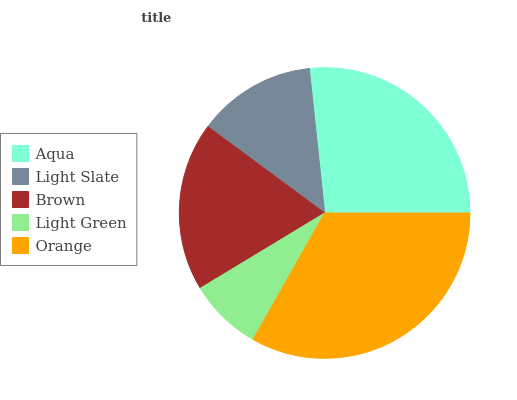Is Light Green the minimum?
Answer yes or no. Yes. Is Orange the maximum?
Answer yes or no. Yes. Is Light Slate the minimum?
Answer yes or no. No. Is Light Slate the maximum?
Answer yes or no. No. Is Aqua greater than Light Slate?
Answer yes or no. Yes. Is Light Slate less than Aqua?
Answer yes or no. Yes. Is Light Slate greater than Aqua?
Answer yes or no. No. Is Aqua less than Light Slate?
Answer yes or no. No. Is Brown the high median?
Answer yes or no. Yes. Is Brown the low median?
Answer yes or no. Yes. Is Light Green the high median?
Answer yes or no. No. Is Aqua the low median?
Answer yes or no. No. 